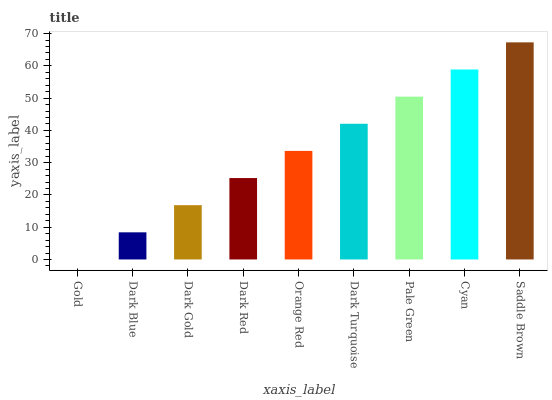Is Gold the minimum?
Answer yes or no. Yes. Is Saddle Brown the maximum?
Answer yes or no. Yes. Is Dark Blue the minimum?
Answer yes or no. No. Is Dark Blue the maximum?
Answer yes or no. No. Is Dark Blue greater than Gold?
Answer yes or no. Yes. Is Gold less than Dark Blue?
Answer yes or no. Yes. Is Gold greater than Dark Blue?
Answer yes or no. No. Is Dark Blue less than Gold?
Answer yes or no. No. Is Orange Red the high median?
Answer yes or no. Yes. Is Orange Red the low median?
Answer yes or no. Yes. Is Gold the high median?
Answer yes or no. No. Is Dark Red the low median?
Answer yes or no. No. 